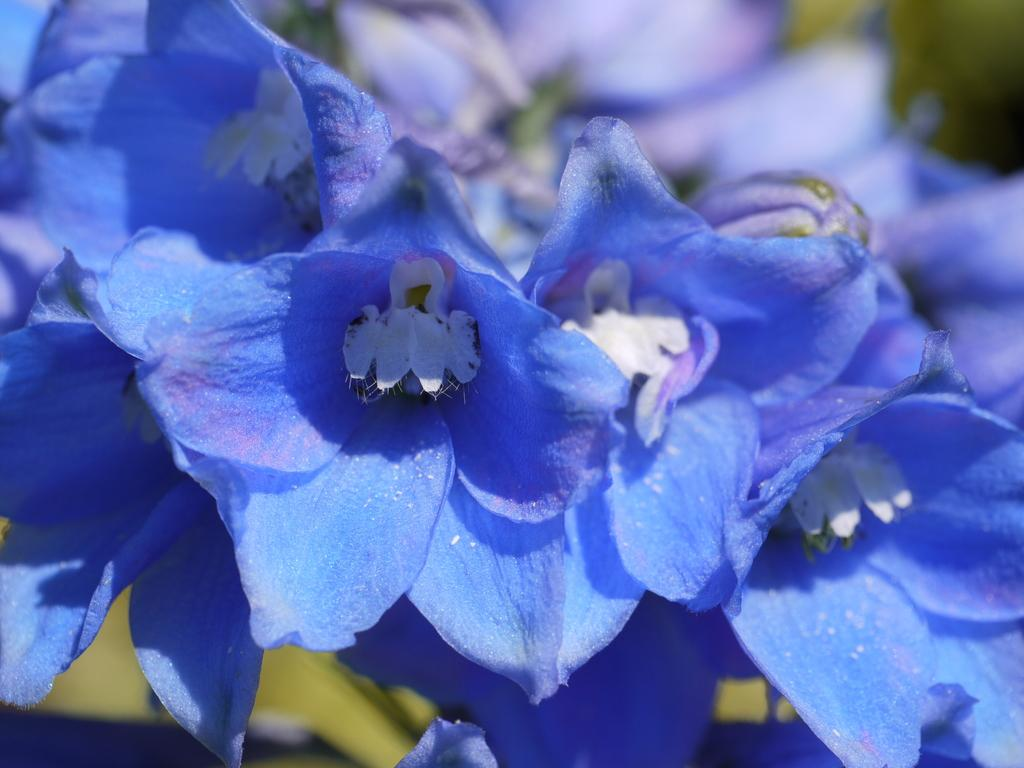What type of flowers can be seen in the image? There are blue flowers in the image. Can you describe the background of the image? The background of the image is blurry. What type of industry can be seen in the background of the image? There is no industry present in the image; the background is blurry and does not show any specific setting or environment. 